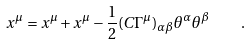<formula> <loc_0><loc_0><loc_500><loc_500>x ^ { \mu } = x ^ { \mu } + x ^ { \mu } - { \frac { 1 } { 2 } } ( C \Gamma ^ { \mu } ) _ { \alpha \beta } \theta ^ { \alpha } \theta ^ { \beta } \quad .</formula> 